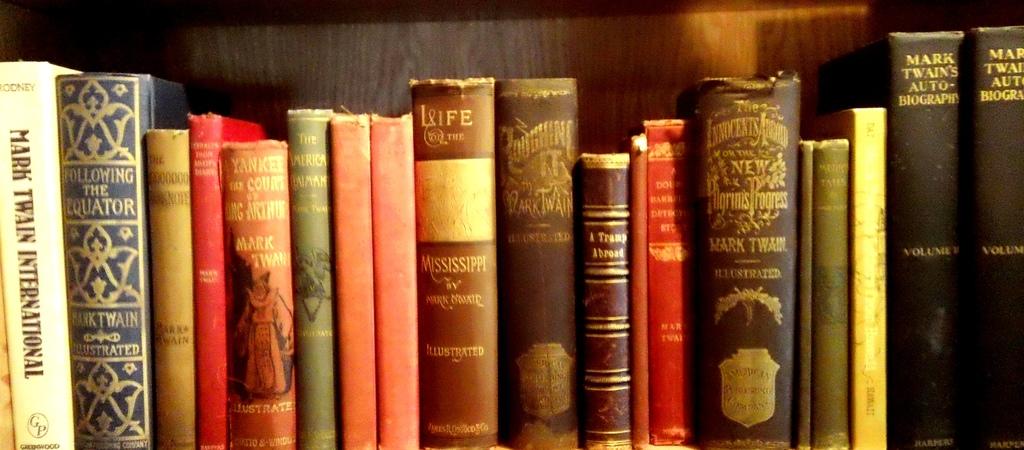What author is on the right books?
Your answer should be compact. Mark twain. Which one of these is "following the equator?"?
Keep it short and to the point. Mark twain. 